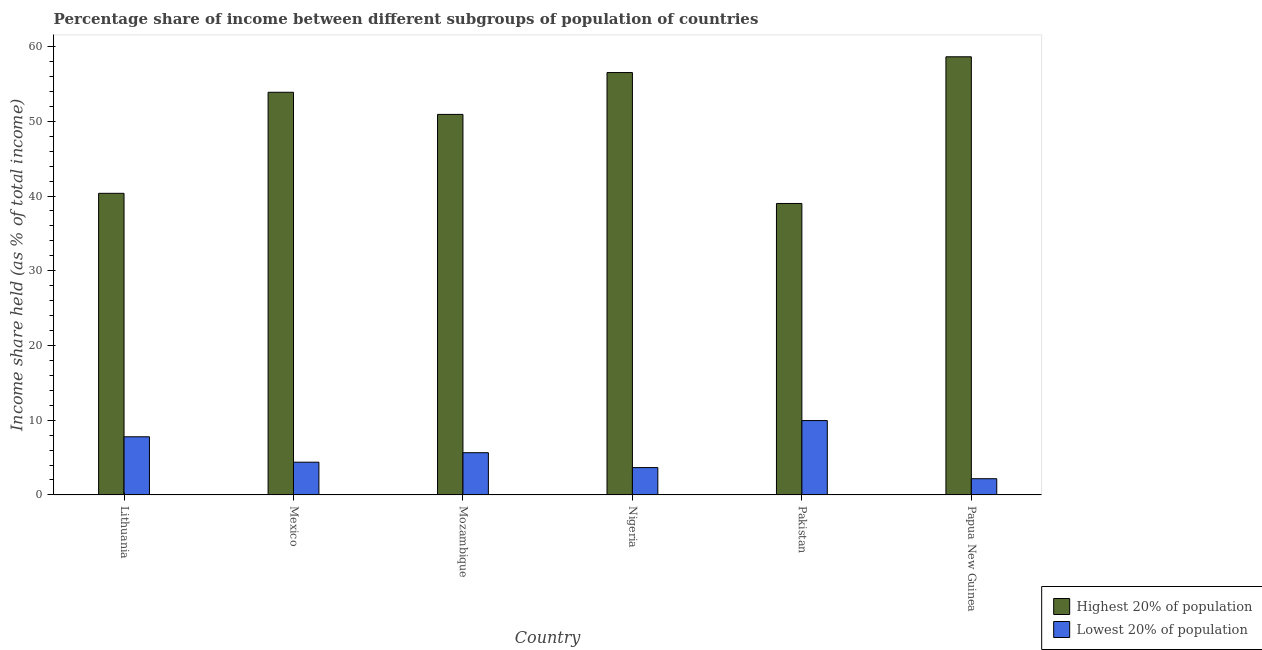How many groups of bars are there?
Your response must be concise. 6. What is the label of the 3rd group of bars from the left?
Give a very brief answer. Mozambique. What is the income share held by highest 20% of the population in Mexico?
Provide a short and direct response. 53.88. Across all countries, what is the maximum income share held by highest 20% of the population?
Provide a succinct answer. 58.63. Across all countries, what is the minimum income share held by lowest 20% of the population?
Your answer should be very brief. 2.17. In which country was the income share held by lowest 20% of the population maximum?
Offer a very short reply. Pakistan. What is the total income share held by lowest 20% of the population in the graph?
Give a very brief answer. 33.59. What is the difference between the income share held by highest 20% of the population in Mexico and that in Nigeria?
Ensure brevity in your answer.  -2.64. What is the difference between the income share held by lowest 20% of the population in Lithuania and the income share held by highest 20% of the population in Papua New Guinea?
Offer a very short reply. -50.85. What is the average income share held by lowest 20% of the population per country?
Provide a short and direct response. 5.6. What is the difference between the income share held by lowest 20% of the population and income share held by highest 20% of the population in Lithuania?
Your response must be concise. -32.58. In how many countries, is the income share held by lowest 20% of the population greater than 22 %?
Provide a succinct answer. 0. What is the ratio of the income share held by lowest 20% of the population in Mexico to that in Nigeria?
Your answer should be compact. 1.2. What is the difference between the highest and the second highest income share held by lowest 20% of the population?
Your answer should be very brief. 2.17. What is the difference between the highest and the lowest income share held by lowest 20% of the population?
Your answer should be compact. 7.78. In how many countries, is the income share held by highest 20% of the population greater than the average income share held by highest 20% of the population taken over all countries?
Your response must be concise. 4. What does the 1st bar from the left in Papua New Guinea represents?
Offer a terse response. Highest 20% of population. What does the 2nd bar from the right in Nigeria represents?
Offer a very short reply. Highest 20% of population. How many bars are there?
Give a very brief answer. 12. What is the difference between two consecutive major ticks on the Y-axis?
Provide a succinct answer. 10. Are the values on the major ticks of Y-axis written in scientific E-notation?
Your answer should be compact. No. Does the graph contain grids?
Ensure brevity in your answer.  No. Where does the legend appear in the graph?
Your answer should be very brief. Bottom right. How many legend labels are there?
Make the answer very short. 2. How are the legend labels stacked?
Your answer should be compact. Vertical. What is the title of the graph?
Your answer should be very brief. Percentage share of income between different subgroups of population of countries. What is the label or title of the Y-axis?
Make the answer very short. Income share held (as % of total income). What is the Income share held (as % of total income) in Highest 20% of population in Lithuania?
Offer a terse response. 40.36. What is the Income share held (as % of total income) of Lowest 20% of population in Lithuania?
Provide a short and direct response. 7.78. What is the Income share held (as % of total income) in Highest 20% of population in Mexico?
Ensure brevity in your answer.  53.88. What is the Income share held (as % of total income) in Lowest 20% of population in Mexico?
Give a very brief answer. 4.38. What is the Income share held (as % of total income) of Highest 20% of population in Mozambique?
Provide a short and direct response. 50.92. What is the Income share held (as % of total income) of Lowest 20% of population in Mozambique?
Your response must be concise. 5.65. What is the Income share held (as % of total income) in Highest 20% of population in Nigeria?
Ensure brevity in your answer.  56.52. What is the Income share held (as % of total income) of Lowest 20% of population in Nigeria?
Your response must be concise. 3.66. What is the Income share held (as % of total income) in Lowest 20% of population in Pakistan?
Offer a very short reply. 9.95. What is the Income share held (as % of total income) in Highest 20% of population in Papua New Guinea?
Provide a succinct answer. 58.63. What is the Income share held (as % of total income) of Lowest 20% of population in Papua New Guinea?
Make the answer very short. 2.17. Across all countries, what is the maximum Income share held (as % of total income) of Highest 20% of population?
Make the answer very short. 58.63. Across all countries, what is the maximum Income share held (as % of total income) in Lowest 20% of population?
Your response must be concise. 9.95. Across all countries, what is the minimum Income share held (as % of total income) in Highest 20% of population?
Give a very brief answer. 39. Across all countries, what is the minimum Income share held (as % of total income) in Lowest 20% of population?
Make the answer very short. 2.17. What is the total Income share held (as % of total income) of Highest 20% of population in the graph?
Your answer should be compact. 299.31. What is the total Income share held (as % of total income) of Lowest 20% of population in the graph?
Offer a terse response. 33.59. What is the difference between the Income share held (as % of total income) of Highest 20% of population in Lithuania and that in Mexico?
Your response must be concise. -13.52. What is the difference between the Income share held (as % of total income) in Lowest 20% of population in Lithuania and that in Mexico?
Your response must be concise. 3.4. What is the difference between the Income share held (as % of total income) in Highest 20% of population in Lithuania and that in Mozambique?
Your answer should be very brief. -10.56. What is the difference between the Income share held (as % of total income) in Lowest 20% of population in Lithuania and that in Mozambique?
Give a very brief answer. 2.13. What is the difference between the Income share held (as % of total income) of Highest 20% of population in Lithuania and that in Nigeria?
Your answer should be very brief. -16.16. What is the difference between the Income share held (as % of total income) in Lowest 20% of population in Lithuania and that in Nigeria?
Your answer should be very brief. 4.12. What is the difference between the Income share held (as % of total income) in Highest 20% of population in Lithuania and that in Pakistan?
Ensure brevity in your answer.  1.36. What is the difference between the Income share held (as % of total income) in Lowest 20% of population in Lithuania and that in Pakistan?
Your answer should be compact. -2.17. What is the difference between the Income share held (as % of total income) in Highest 20% of population in Lithuania and that in Papua New Guinea?
Provide a short and direct response. -18.27. What is the difference between the Income share held (as % of total income) in Lowest 20% of population in Lithuania and that in Papua New Guinea?
Your response must be concise. 5.61. What is the difference between the Income share held (as % of total income) in Highest 20% of population in Mexico and that in Mozambique?
Make the answer very short. 2.96. What is the difference between the Income share held (as % of total income) of Lowest 20% of population in Mexico and that in Mozambique?
Offer a terse response. -1.27. What is the difference between the Income share held (as % of total income) of Highest 20% of population in Mexico and that in Nigeria?
Your response must be concise. -2.64. What is the difference between the Income share held (as % of total income) of Lowest 20% of population in Mexico and that in Nigeria?
Your answer should be compact. 0.72. What is the difference between the Income share held (as % of total income) in Highest 20% of population in Mexico and that in Pakistan?
Provide a succinct answer. 14.88. What is the difference between the Income share held (as % of total income) in Lowest 20% of population in Mexico and that in Pakistan?
Offer a terse response. -5.57. What is the difference between the Income share held (as % of total income) of Highest 20% of population in Mexico and that in Papua New Guinea?
Your answer should be very brief. -4.75. What is the difference between the Income share held (as % of total income) in Lowest 20% of population in Mexico and that in Papua New Guinea?
Your response must be concise. 2.21. What is the difference between the Income share held (as % of total income) in Lowest 20% of population in Mozambique and that in Nigeria?
Ensure brevity in your answer.  1.99. What is the difference between the Income share held (as % of total income) in Highest 20% of population in Mozambique and that in Pakistan?
Provide a short and direct response. 11.92. What is the difference between the Income share held (as % of total income) of Highest 20% of population in Mozambique and that in Papua New Guinea?
Your response must be concise. -7.71. What is the difference between the Income share held (as % of total income) in Lowest 20% of population in Mozambique and that in Papua New Guinea?
Your answer should be compact. 3.48. What is the difference between the Income share held (as % of total income) of Highest 20% of population in Nigeria and that in Pakistan?
Give a very brief answer. 17.52. What is the difference between the Income share held (as % of total income) in Lowest 20% of population in Nigeria and that in Pakistan?
Provide a succinct answer. -6.29. What is the difference between the Income share held (as % of total income) in Highest 20% of population in Nigeria and that in Papua New Guinea?
Offer a terse response. -2.11. What is the difference between the Income share held (as % of total income) in Lowest 20% of population in Nigeria and that in Papua New Guinea?
Offer a terse response. 1.49. What is the difference between the Income share held (as % of total income) of Highest 20% of population in Pakistan and that in Papua New Guinea?
Ensure brevity in your answer.  -19.63. What is the difference between the Income share held (as % of total income) in Lowest 20% of population in Pakistan and that in Papua New Guinea?
Make the answer very short. 7.78. What is the difference between the Income share held (as % of total income) of Highest 20% of population in Lithuania and the Income share held (as % of total income) of Lowest 20% of population in Mexico?
Give a very brief answer. 35.98. What is the difference between the Income share held (as % of total income) in Highest 20% of population in Lithuania and the Income share held (as % of total income) in Lowest 20% of population in Mozambique?
Your answer should be very brief. 34.71. What is the difference between the Income share held (as % of total income) in Highest 20% of population in Lithuania and the Income share held (as % of total income) in Lowest 20% of population in Nigeria?
Make the answer very short. 36.7. What is the difference between the Income share held (as % of total income) of Highest 20% of population in Lithuania and the Income share held (as % of total income) of Lowest 20% of population in Pakistan?
Offer a very short reply. 30.41. What is the difference between the Income share held (as % of total income) in Highest 20% of population in Lithuania and the Income share held (as % of total income) in Lowest 20% of population in Papua New Guinea?
Ensure brevity in your answer.  38.19. What is the difference between the Income share held (as % of total income) of Highest 20% of population in Mexico and the Income share held (as % of total income) of Lowest 20% of population in Mozambique?
Give a very brief answer. 48.23. What is the difference between the Income share held (as % of total income) in Highest 20% of population in Mexico and the Income share held (as % of total income) in Lowest 20% of population in Nigeria?
Provide a short and direct response. 50.22. What is the difference between the Income share held (as % of total income) in Highest 20% of population in Mexico and the Income share held (as % of total income) in Lowest 20% of population in Pakistan?
Your answer should be compact. 43.93. What is the difference between the Income share held (as % of total income) of Highest 20% of population in Mexico and the Income share held (as % of total income) of Lowest 20% of population in Papua New Guinea?
Your response must be concise. 51.71. What is the difference between the Income share held (as % of total income) in Highest 20% of population in Mozambique and the Income share held (as % of total income) in Lowest 20% of population in Nigeria?
Provide a short and direct response. 47.26. What is the difference between the Income share held (as % of total income) of Highest 20% of population in Mozambique and the Income share held (as % of total income) of Lowest 20% of population in Pakistan?
Your answer should be very brief. 40.97. What is the difference between the Income share held (as % of total income) in Highest 20% of population in Mozambique and the Income share held (as % of total income) in Lowest 20% of population in Papua New Guinea?
Provide a short and direct response. 48.75. What is the difference between the Income share held (as % of total income) of Highest 20% of population in Nigeria and the Income share held (as % of total income) of Lowest 20% of population in Pakistan?
Your answer should be compact. 46.57. What is the difference between the Income share held (as % of total income) in Highest 20% of population in Nigeria and the Income share held (as % of total income) in Lowest 20% of population in Papua New Guinea?
Your answer should be compact. 54.35. What is the difference between the Income share held (as % of total income) of Highest 20% of population in Pakistan and the Income share held (as % of total income) of Lowest 20% of population in Papua New Guinea?
Provide a succinct answer. 36.83. What is the average Income share held (as % of total income) of Highest 20% of population per country?
Your answer should be compact. 49.88. What is the average Income share held (as % of total income) in Lowest 20% of population per country?
Make the answer very short. 5.6. What is the difference between the Income share held (as % of total income) of Highest 20% of population and Income share held (as % of total income) of Lowest 20% of population in Lithuania?
Provide a succinct answer. 32.58. What is the difference between the Income share held (as % of total income) of Highest 20% of population and Income share held (as % of total income) of Lowest 20% of population in Mexico?
Provide a succinct answer. 49.5. What is the difference between the Income share held (as % of total income) of Highest 20% of population and Income share held (as % of total income) of Lowest 20% of population in Mozambique?
Your answer should be very brief. 45.27. What is the difference between the Income share held (as % of total income) in Highest 20% of population and Income share held (as % of total income) in Lowest 20% of population in Nigeria?
Provide a short and direct response. 52.86. What is the difference between the Income share held (as % of total income) in Highest 20% of population and Income share held (as % of total income) in Lowest 20% of population in Pakistan?
Your answer should be very brief. 29.05. What is the difference between the Income share held (as % of total income) of Highest 20% of population and Income share held (as % of total income) of Lowest 20% of population in Papua New Guinea?
Offer a very short reply. 56.46. What is the ratio of the Income share held (as % of total income) of Highest 20% of population in Lithuania to that in Mexico?
Your answer should be very brief. 0.75. What is the ratio of the Income share held (as % of total income) in Lowest 20% of population in Lithuania to that in Mexico?
Provide a succinct answer. 1.78. What is the ratio of the Income share held (as % of total income) in Highest 20% of population in Lithuania to that in Mozambique?
Provide a short and direct response. 0.79. What is the ratio of the Income share held (as % of total income) of Lowest 20% of population in Lithuania to that in Mozambique?
Ensure brevity in your answer.  1.38. What is the ratio of the Income share held (as % of total income) in Highest 20% of population in Lithuania to that in Nigeria?
Your response must be concise. 0.71. What is the ratio of the Income share held (as % of total income) of Lowest 20% of population in Lithuania to that in Nigeria?
Make the answer very short. 2.13. What is the ratio of the Income share held (as % of total income) of Highest 20% of population in Lithuania to that in Pakistan?
Provide a succinct answer. 1.03. What is the ratio of the Income share held (as % of total income) of Lowest 20% of population in Lithuania to that in Pakistan?
Your response must be concise. 0.78. What is the ratio of the Income share held (as % of total income) of Highest 20% of population in Lithuania to that in Papua New Guinea?
Offer a terse response. 0.69. What is the ratio of the Income share held (as % of total income) of Lowest 20% of population in Lithuania to that in Papua New Guinea?
Your answer should be compact. 3.59. What is the ratio of the Income share held (as % of total income) in Highest 20% of population in Mexico to that in Mozambique?
Provide a short and direct response. 1.06. What is the ratio of the Income share held (as % of total income) in Lowest 20% of population in Mexico to that in Mozambique?
Ensure brevity in your answer.  0.78. What is the ratio of the Income share held (as % of total income) of Highest 20% of population in Mexico to that in Nigeria?
Provide a short and direct response. 0.95. What is the ratio of the Income share held (as % of total income) of Lowest 20% of population in Mexico to that in Nigeria?
Offer a terse response. 1.2. What is the ratio of the Income share held (as % of total income) in Highest 20% of population in Mexico to that in Pakistan?
Provide a succinct answer. 1.38. What is the ratio of the Income share held (as % of total income) of Lowest 20% of population in Mexico to that in Pakistan?
Give a very brief answer. 0.44. What is the ratio of the Income share held (as % of total income) of Highest 20% of population in Mexico to that in Papua New Guinea?
Your answer should be compact. 0.92. What is the ratio of the Income share held (as % of total income) of Lowest 20% of population in Mexico to that in Papua New Guinea?
Your answer should be compact. 2.02. What is the ratio of the Income share held (as % of total income) in Highest 20% of population in Mozambique to that in Nigeria?
Offer a very short reply. 0.9. What is the ratio of the Income share held (as % of total income) of Lowest 20% of population in Mozambique to that in Nigeria?
Keep it short and to the point. 1.54. What is the ratio of the Income share held (as % of total income) of Highest 20% of population in Mozambique to that in Pakistan?
Provide a succinct answer. 1.31. What is the ratio of the Income share held (as % of total income) of Lowest 20% of population in Mozambique to that in Pakistan?
Provide a succinct answer. 0.57. What is the ratio of the Income share held (as % of total income) of Highest 20% of population in Mozambique to that in Papua New Guinea?
Provide a short and direct response. 0.87. What is the ratio of the Income share held (as % of total income) of Lowest 20% of population in Mozambique to that in Papua New Guinea?
Your answer should be compact. 2.6. What is the ratio of the Income share held (as % of total income) in Highest 20% of population in Nigeria to that in Pakistan?
Offer a very short reply. 1.45. What is the ratio of the Income share held (as % of total income) of Lowest 20% of population in Nigeria to that in Pakistan?
Your response must be concise. 0.37. What is the ratio of the Income share held (as % of total income) of Highest 20% of population in Nigeria to that in Papua New Guinea?
Your answer should be compact. 0.96. What is the ratio of the Income share held (as % of total income) in Lowest 20% of population in Nigeria to that in Papua New Guinea?
Your response must be concise. 1.69. What is the ratio of the Income share held (as % of total income) in Highest 20% of population in Pakistan to that in Papua New Guinea?
Make the answer very short. 0.67. What is the ratio of the Income share held (as % of total income) in Lowest 20% of population in Pakistan to that in Papua New Guinea?
Offer a very short reply. 4.59. What is the difference between the highest and the second highest Income share held (as % of total income) in Highest 20% of population?
Your response must be concise. 2.11. What is the difference between the highest and the second highest Income share held (as % of total income) in Lowest 20% of population?
Offer a very short reply. 2.17. What is the difference between the highest and the lowest Income share held (as % of total income) in Highest 20% of population?
Ensure brevity in your answer.  19.63. What is the difference between the highest and the lowest Income share held (as % of total income) of Lowest 20% of population?
Your answer should be very brief. 7.78. 